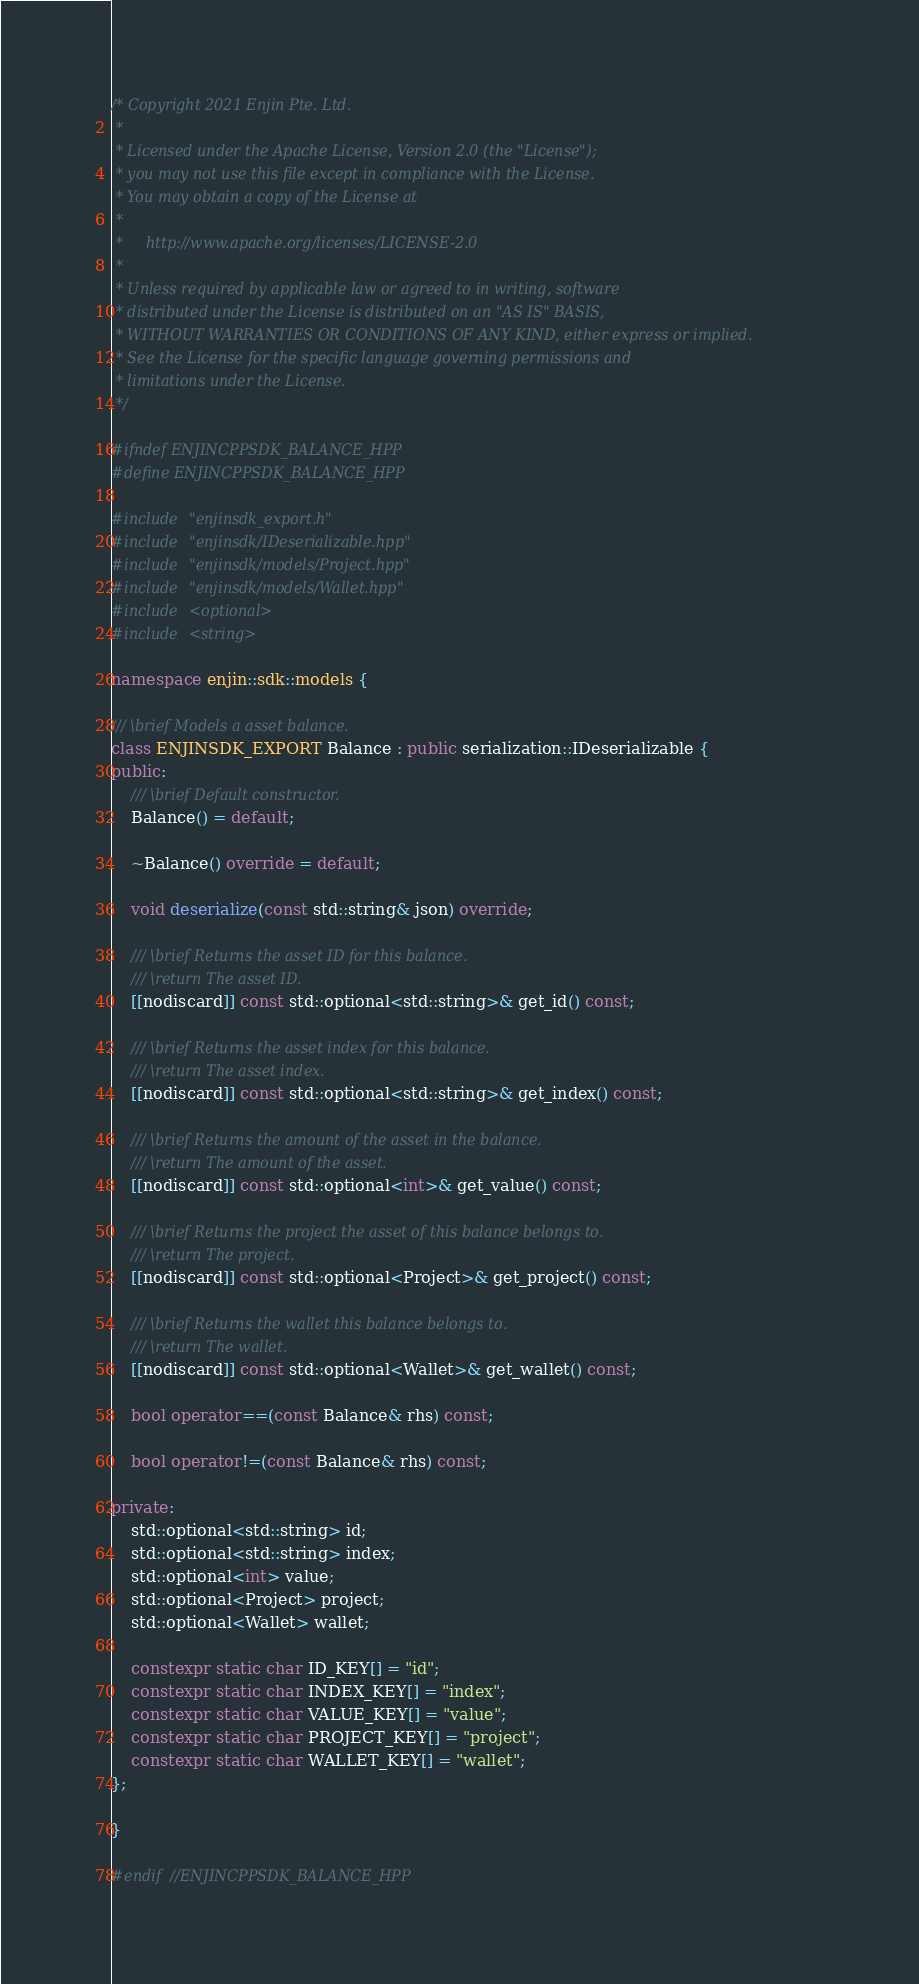Convert code to text. <code><loc_0><loc_0><loc_500><loc_500><_C++_>/* Copyright 2021 Enjin Pte. Ltd.
 *
 * Licensed under the Apache License, Version 2.0 (the "License");
 * you may not use this file except in compliance with the License.
 * You may obtain a copy of the License at
 *
 *     http://www.apache.org/licenses/LICENSE-2.0
 *
 * Unless required by applicable law or agreed to in writing, software
 * distributed under the License is distributed on an "AS IS" BASIS,
 * WITHOUT WARRANTIES OR CONDITIONS OF ANY KIND, either express or implied.
 * See the License for the specific language governing permissions and
 * limitations under the License.
 */

#ifndef ENJINCPPSDK_BALANCE_HPP
#define ENJINCPPSDK_BALANCE_HPP

#include "enjinsdk_export.h"
#include "enjinsdk/IDeserializable.hpp"
#include "enjinsdk/models/Project.hpp"
#include "enjinsdk/models/Wallet.hpp"
#include <optional>
#include <string>

namespace enjin::sdk::models {

/// \brief Models a asset balance.
class ENJINSDK_EXPORT Balance : public serialization::IDeserializable {
public:
    /// \brief Default constructor.
    Balance() = default;

    ~Balance() override = default;

    void deserialize(const std::string& json) override;

    /// \brief Returns the asset ID for this balance.
    /// \return The asset ID.
    [[nodiscard]] const std::optional<std::string>& get_id() const;

    /// \brief Returns the asset index for this balance.
    /// \return The asset index.
    [[nodiscard]] const std::optional<std::string>& get_index() const;

    /// \brief Returns the amount of the asset in the balance.
    /// \return The amount of the asset.
    [[nodiscard]] const std::optional<int>& get_value() const;

    /// \brief Returns the project the asset of this balance belongs to.
    /// \return The project.
    [[nodiscard]] const std::optional<Project>& get_project() const;

    /// \brief Returns the wallet this balance belongs to.
    /// \return The wallet.
    [[nodiscard]] const std::optional<Wallet>& get_wallet() const;

    bool operator==(const Balance& rhs) const;

    bool operator!=(const Balance& rhs) const;

private:
    std::optional<std::string> id;
    std::optional<std::string> index;
    std::optional<int> value;
    std::optional<Project> project;
    std::optional<Wallet> wallet;

    constexpr static char ID_KEY[] = "id";
    constexpr static char INDEX_KEY[] = "index";
    constexpr static char VALUE_KEY[] = "value";
    constexpr static char PROJECT_KEY[] = "project";
    constexpr static char WALLET_KEY[] = "wallet";
};

}

#endif //ENJINCPPSDK_BALANCE_HPP
</code> 